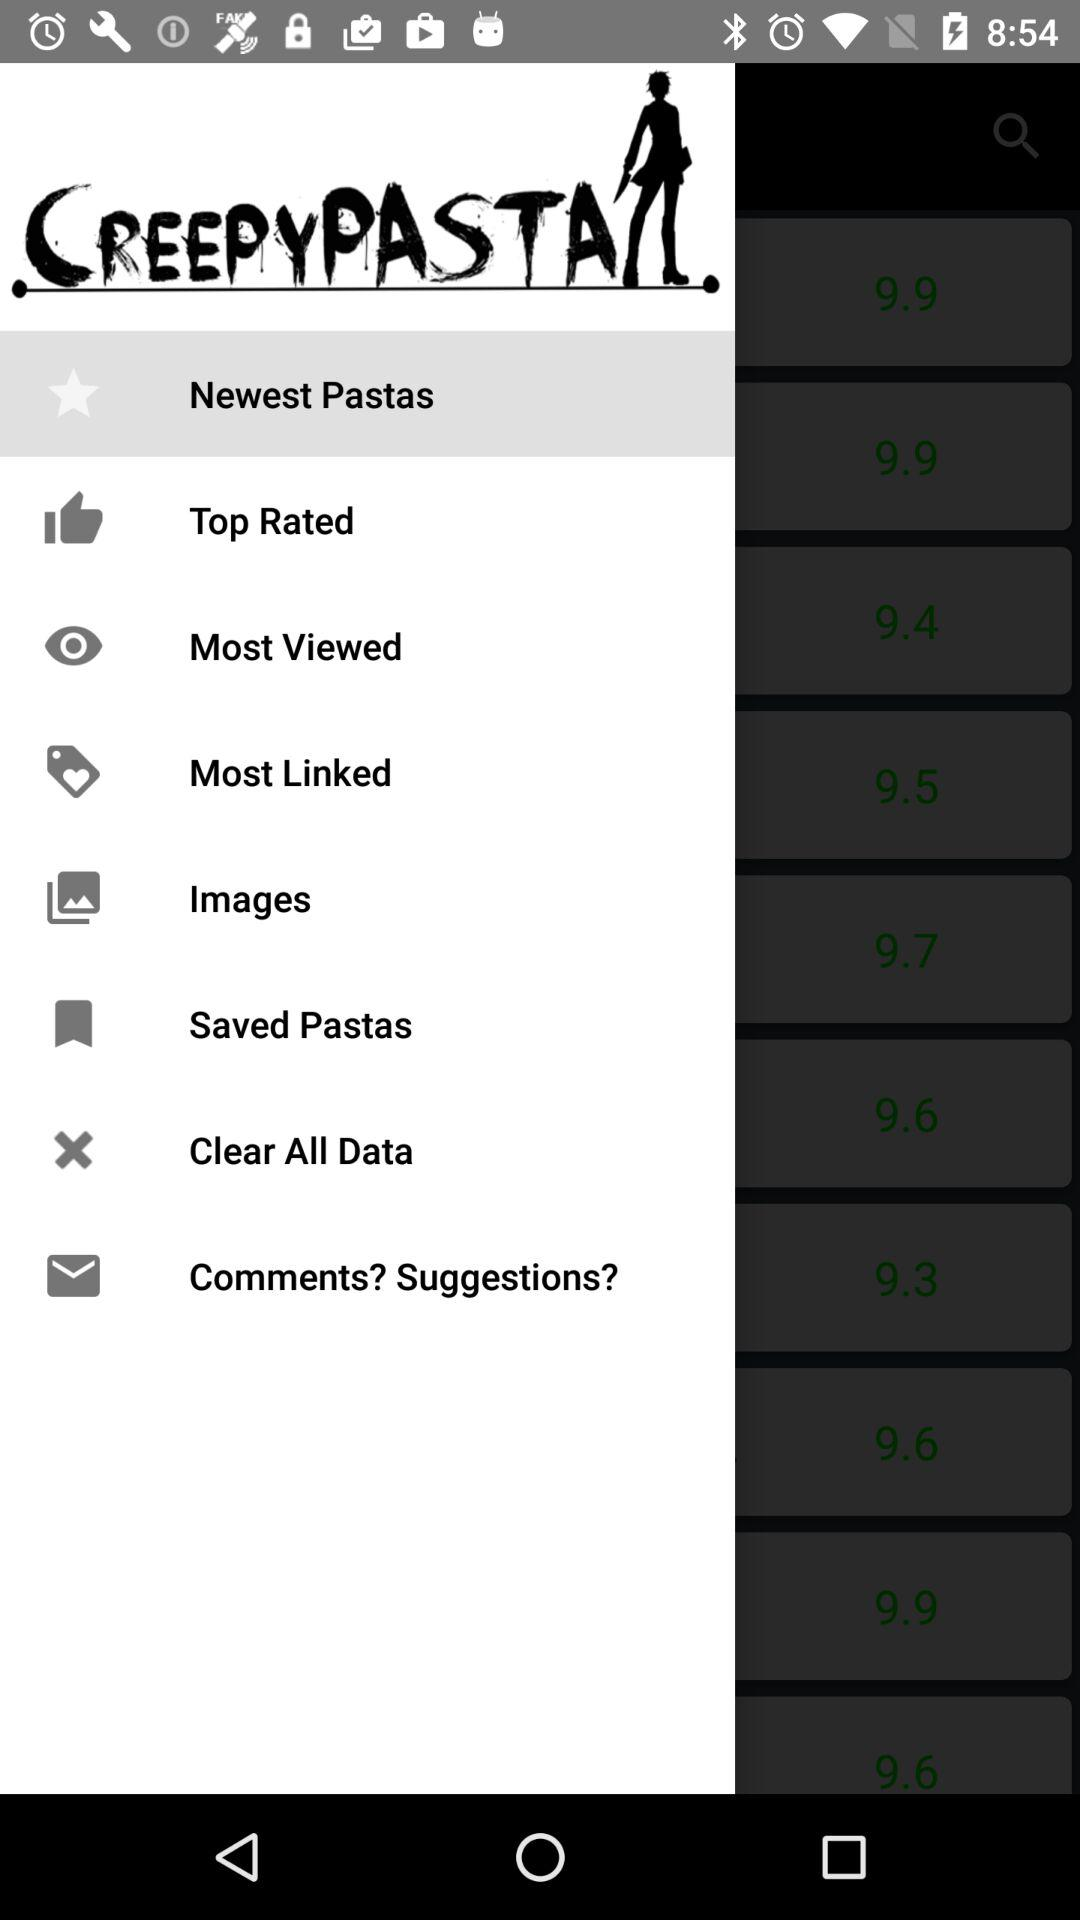What is the application name? The application name is "CREEPYPASTA". 